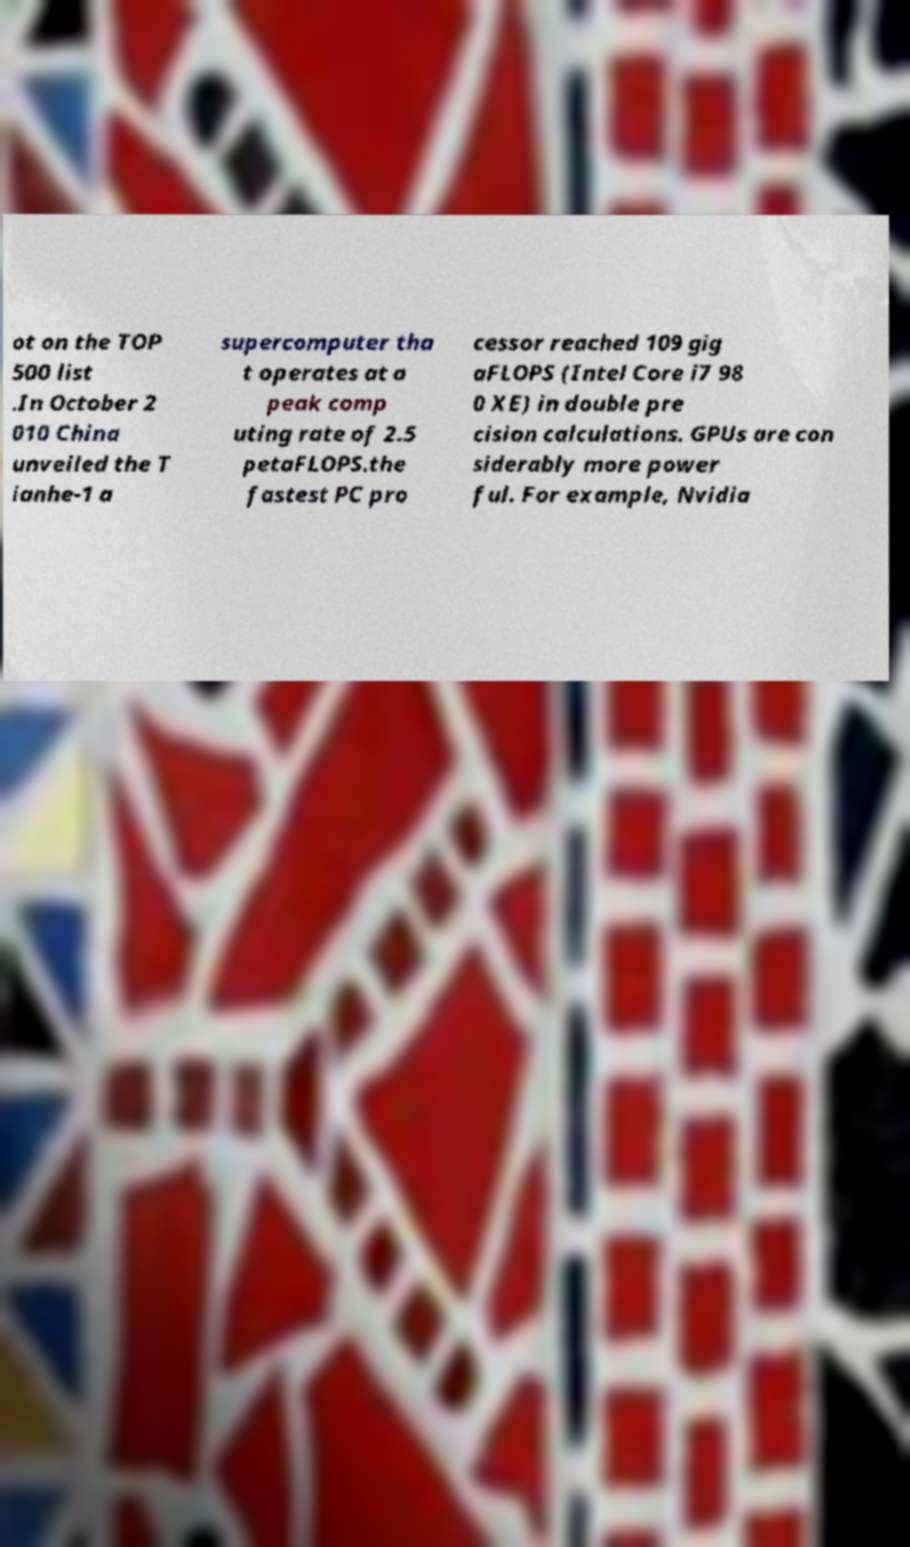For documentation purposes, I need the text within this image transcribed. Could you provide that? ot on the TOP 500 list .In October 2 010 China unveiled the T ianhe-1 a supercomputer tha t operates at a peak comp uting rate of 2.5 petaFLOPS.the fastest PC pro cessor reached 109 gig aFLOPS (Intel Core i7 98 0 XE) in double pre cision calculations. GPUs are con siderably more power ful. For example, Nvidia 